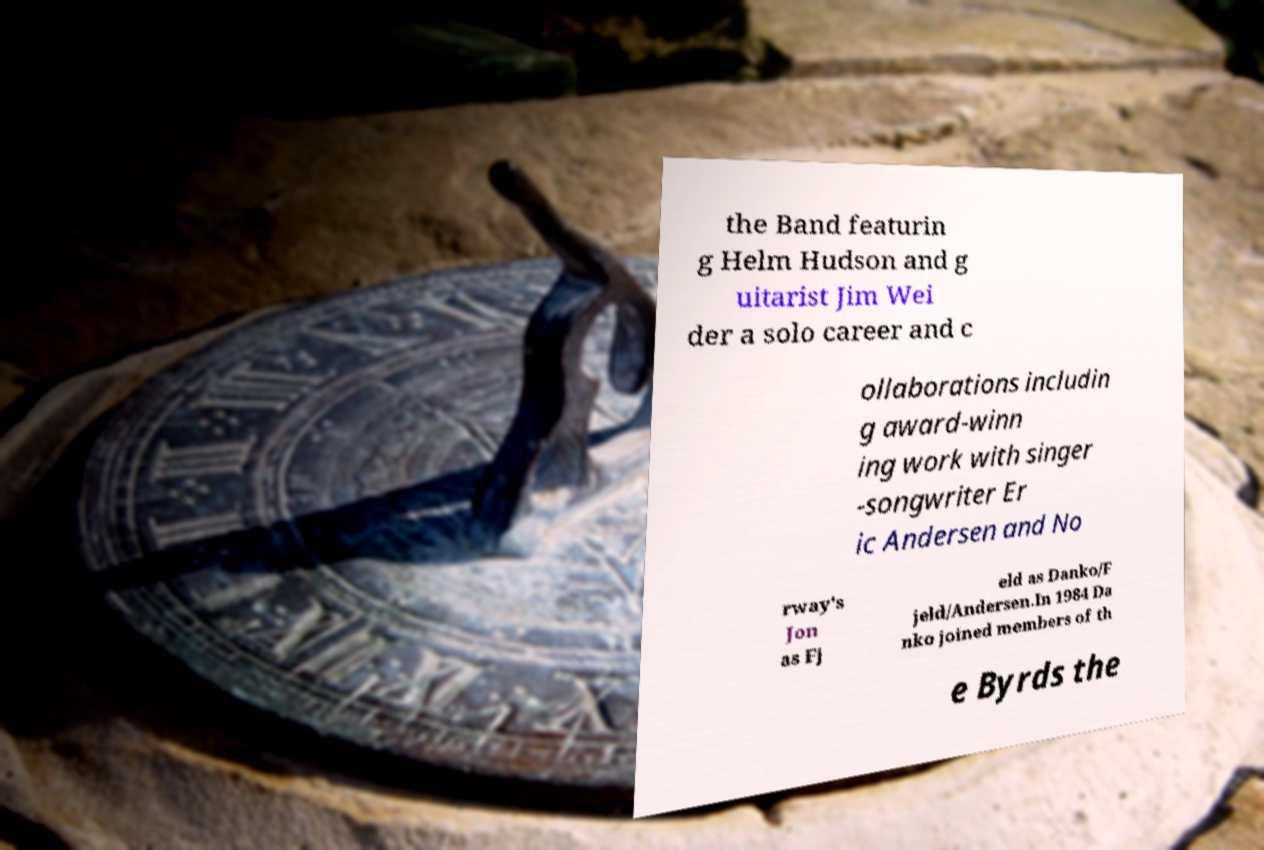Could you extract and type out the text from this image? the Band featurin g Helm Hudson and g uitarist Jim Wei der a solo career and c ollaborations includin g award-winn ing work with singer -songwriter Er ic Andersen and No rway's Jon as Fj eld as Danko/F jeld/Andersen.In 1984 Da nko joined members of th e Byrds the 